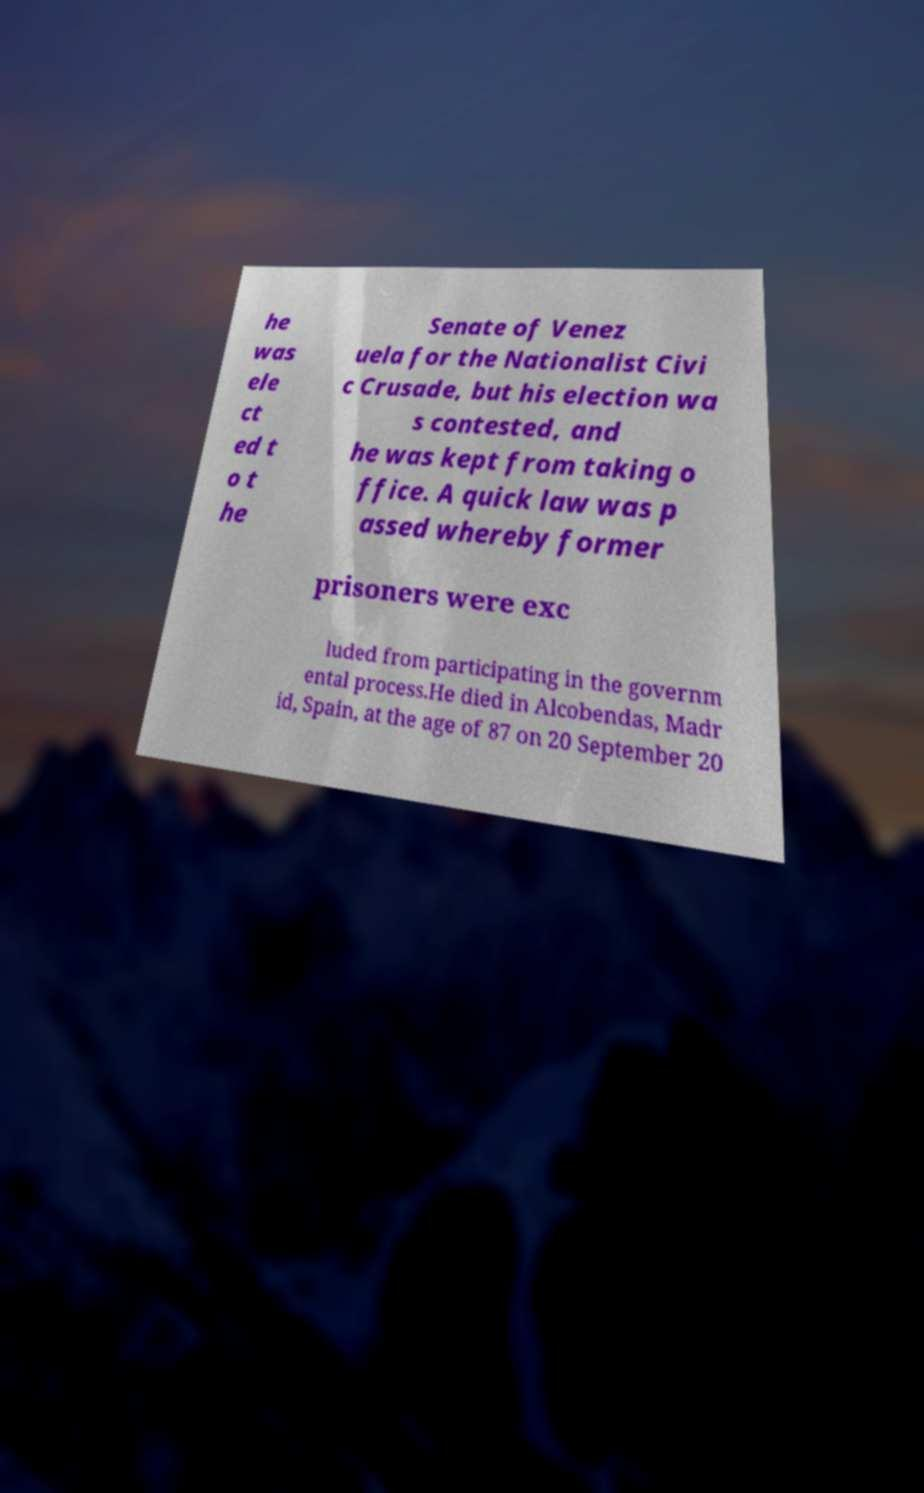What messages or text are displayed in this image? I need them in a readable, typed format. he was ele ct ed t o t he Senate of Venez uela for the Nationalist Civi c Crusade, but his election wa s contested, and he was kept from taking o ffice. A quick law was p assed whereby former prisoners were exc luded from participating in the governm ental process.He died in Alcobendas, Madr id, Spain, at the age of 87 on 20 September 20 